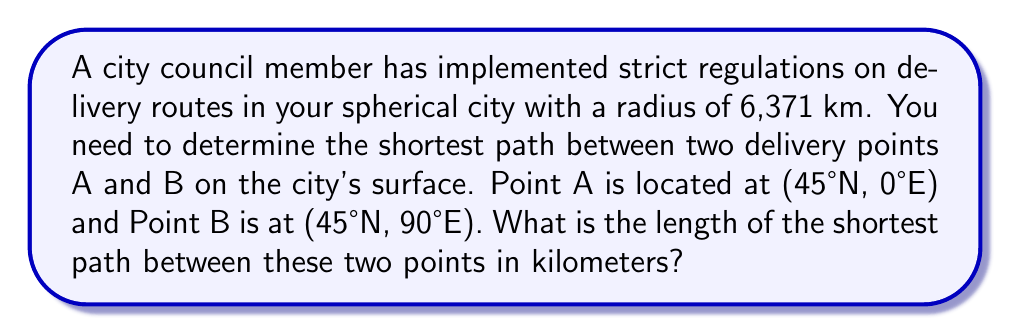Give your solution to this math problem. To solve this problem, we need to use the great circle distance formula, as the shortest path between two points on a sphere is along a great circle. Here's the step-by-step solution:

1. Convert the given coordinates to radians:
   $\phi_1 = 45° \times \frac{\pi}{180} = \frac{\pi}{4}$ (latitude of A)
   $\lambda_1 = 0° \times \frac{\pi}{180} = 0$ (longitude of A)
   $\phi_2 = 45° \times \frac{\pi}{180} = \frac{\pi}{4}$ (latitude of B)
   $\lambda_2 = 90° \times \frac{\pi}{180} = \frac{\pi}{2}$ (longitude of B)

2. Use the great circle distance formula:
   $$\Delta\sigma = \arccos(\sin\phi_1 \sin\phi_2 + \cos\phi_1 \cos\phi_2 \cos(\lambda_2 - \lambda_1))$$

3. Substitute the values:
   $$\Delta\sigma = \arccos(\sin\frac{\pi}{4} \sin\frac{\pi}{4} + \cos\frac{\pi}{4} \cos\frac{\pi}{4} \cos(\frac{\pi}{2} - 0))$$

4. Simplify:
   $$\Delta\sigma = \arccos(\frac{1}{2} + \frac{1}{2} \cos\frac{\pi}{2})$$
   $$\Delta\sigma = \arccos(\frac{1}{2} + 0)$$
   $$\Delta\sigma = \arccos(\frac{1}{2})$$
   $$\Delta\sigma = \frac{\pi}{3}$$

5. Calculate the distance:
   $d = R \times \Delta\sigma$
   where $R$ is the radius of the sphere (city)
   $d = 6371 \times \frac{\pi}{3} \approx 6674.56$ km

Therefore, the shortest path between points A and B is approximately 6674.56 km.
Answer: 6674.56 km 